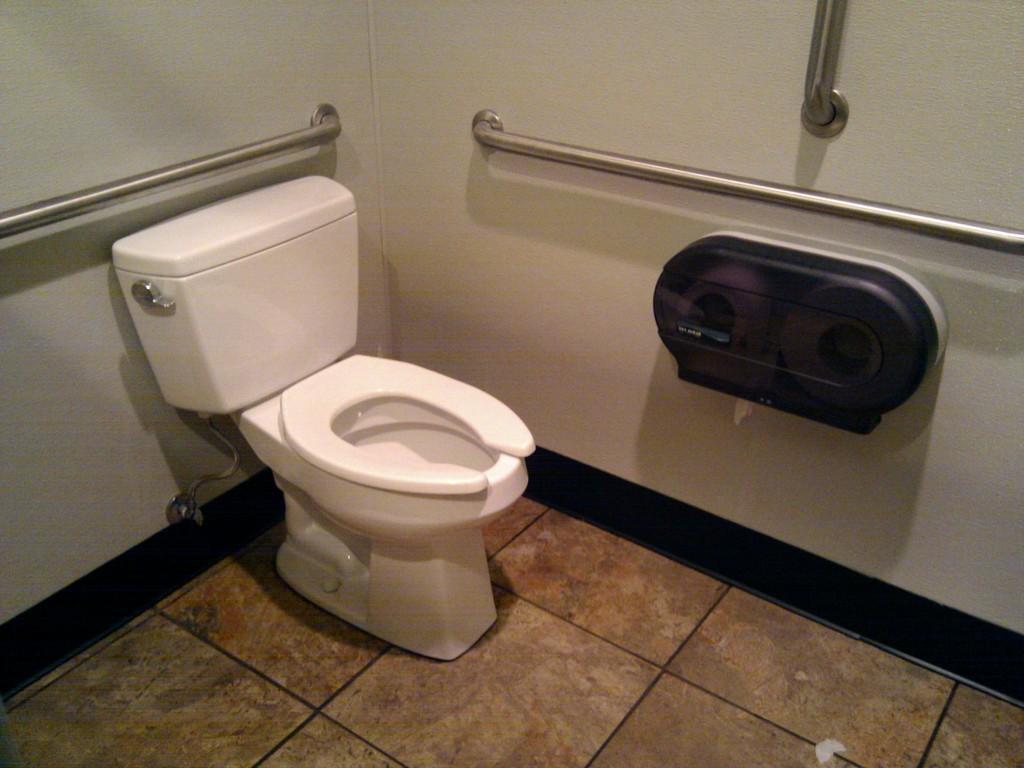In one or two sentences, can you explain what this image depicts? Here in this picture we can see a western toilet present on the floor over there and we can see pores present on the walls over there and on the right side we can also see a tissue roll box present over there. 